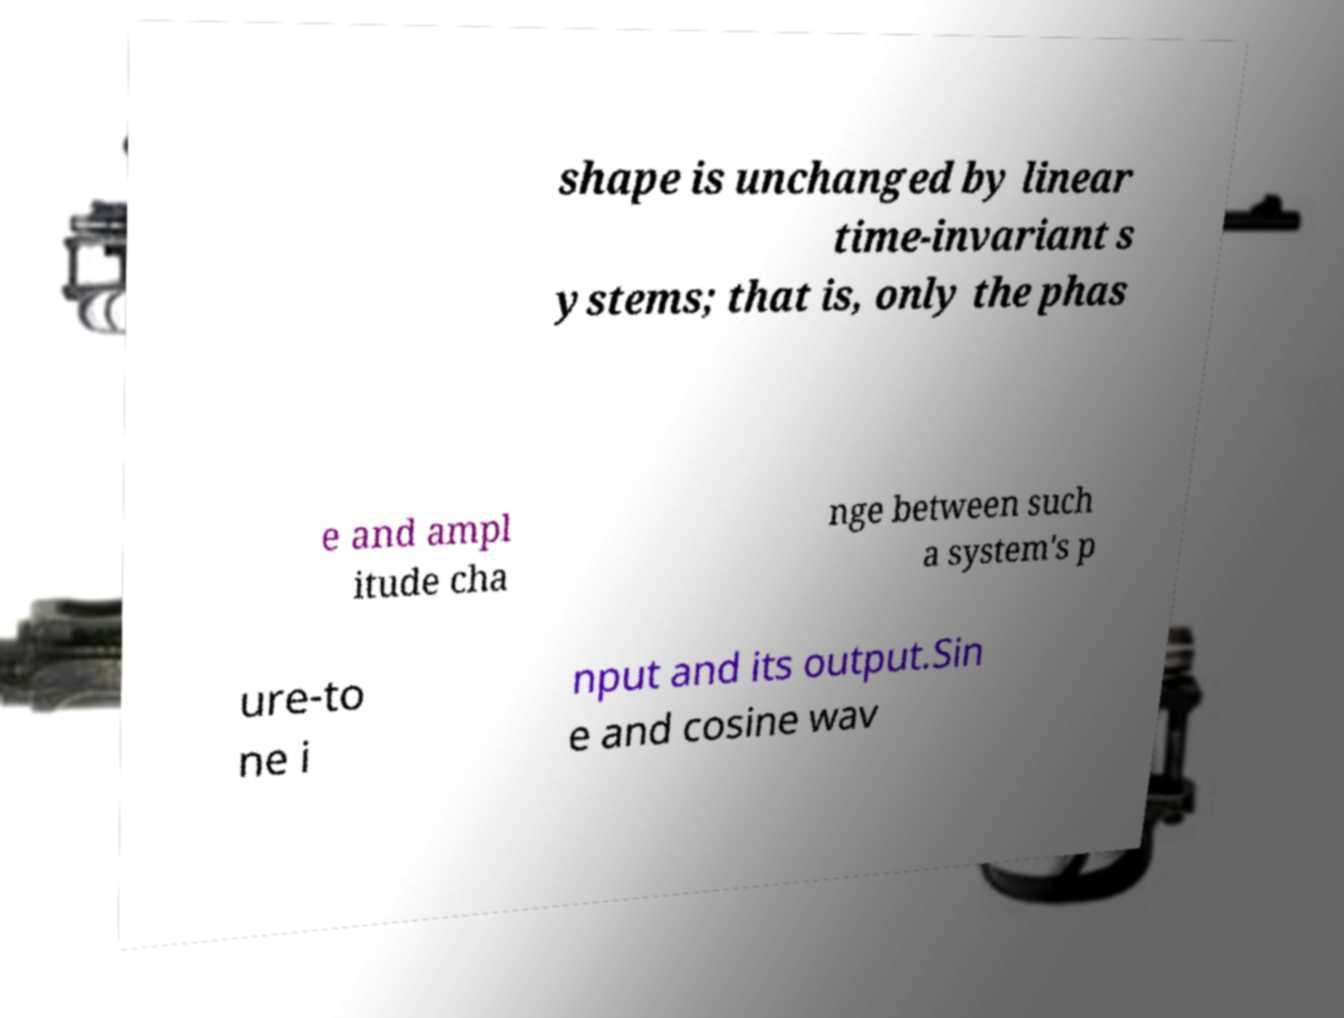Please identify and transcribe the text found in this image. shape is unchanged by linear time-invariant s ystems; that is, only the phas e and ampl itude cha nge between such a system's p ure-to ne i nput and its output.Sin e and cosine wav 